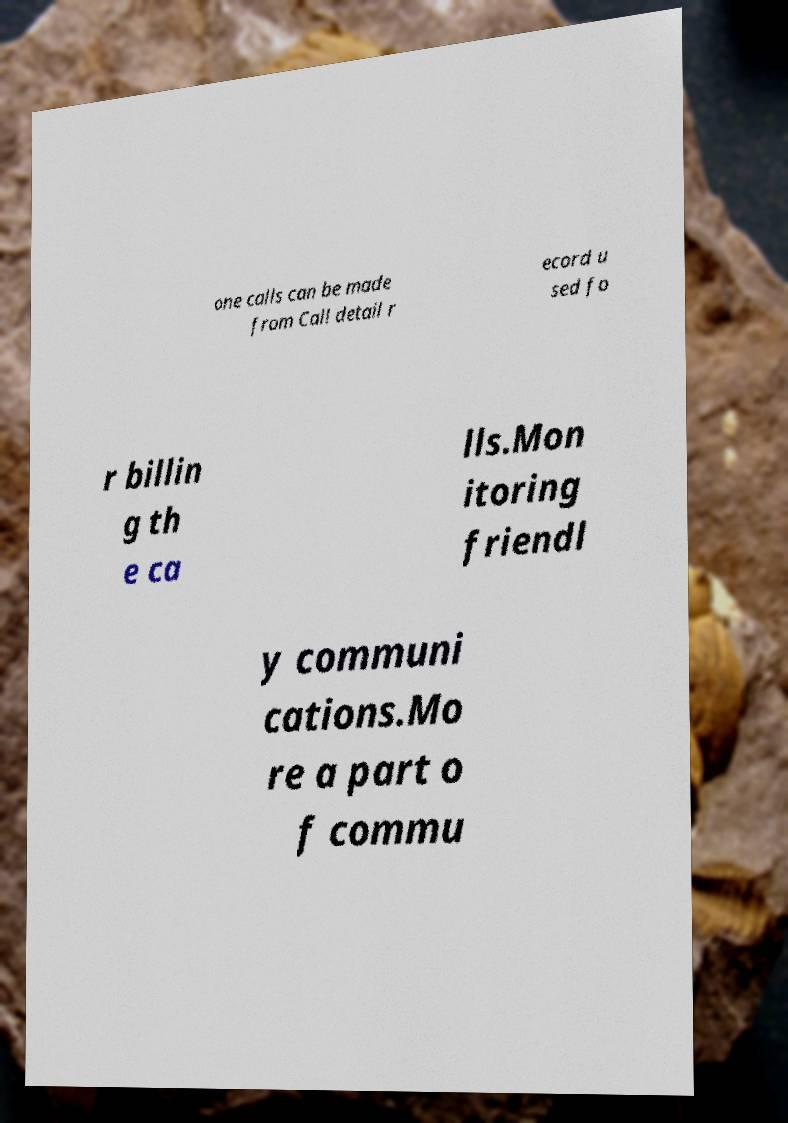Please read and relay the text visible in this image. What does it say? one calls can be made from Call detail r ecord u sed fo r billin g th e ca lls.Mon itoring friendl y communi cations.Mo re a part o f commu 